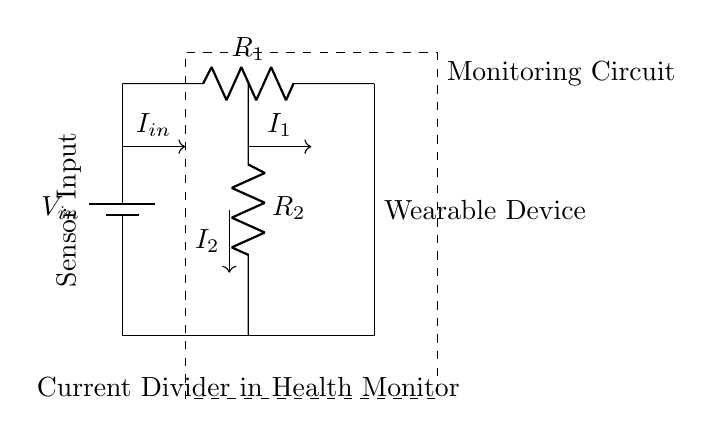What is the input voltage of the circuit? The input voltage is denoted as V_in, representing the voltage supply connected to the circuit.
Answer: V_in What is the component labeled R_1? R_1 is a resistor in the circuit that controls the current flow.
Answer: Resistor Which component measures I_1? I_1 is the current flowing through R_1, which is measured at the top branch of the current divider.
Answer: R_1 How many resistors are present in this current divider? There are two resistors in this circuit, R_1 and R_2, indicated in the diagram.
Answer: Two What is the function of the current divider in this wearable health monitor? The current divider distributes the total input current among the resistors, allowing for measurement of currents I_1 and I_2, which is crucial for monitoring different health metrics.
Answer: Distribute current What is the relationship between I_in, I_1, and I_2? The sum of the currents I_1 and I_2 equals the input current I_in, following the principle of current conservation in parallel circuits (I_in = I_1 + I_2).
Answer: I_in = I_1 + I_2 What is the significance of the sensor input in this circuit? The sensor input represents the point where the health monitoring sensors feed the data into the circuit for analysis and processing.
Answer: Input for sensors 